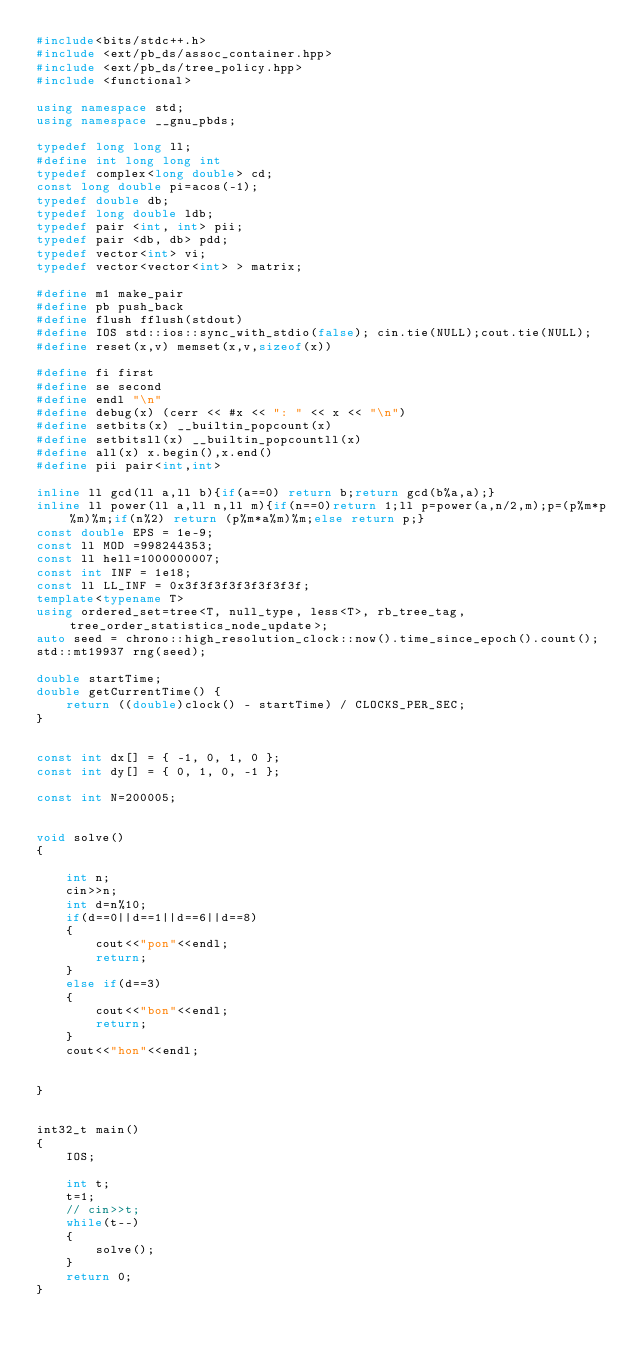Convert code to text. <code><loc_0><loc_0><loc_500><loc_500><_C++_>#include<bits/stdc++.h>
#include <ext/pb_ds/assoc_container.hpp>
#include <ext/pb_ds/tree_policy.hpp>
#include <functional>

using namespace std;
using namespace __gnu_pbds;

typedef long long ll;
#define int long long int
typedef complex<long double> cd;
const long double pi=acos(-1);
typedef double db;
typedef long double ldb;
typedef pair <int, int> pii;
typedef pair <db, db> pdd;
typedef vector<int> vi;
typedef vector<vector<int> > matrix;

#define m1 make_pair
#define pb push_back
#define flush fflush(stdout)
#define IOS std::ios::sync_with_stdio(false); cin.tie(NULL);cout.tie(NULL);
#define reset(x,v) memset(x,v,sizeof(x))

#define fi first
#define se second
#define endl "\n"
#define debug(x) (cerr << #x << ": " << x << "\n")
#define setbits(x) __builtin_popcount(x)
#define setbitsll(x) __builtin_popcountll(x)
#define all(x) x.begin(),x.end()
#define pii pair<int,int>

inline ll gcd(ll a,ll b){if(a==0) return b;return gcd(b%a,a);}
inline ll power(ll a,ll n,ll m){if(n==0)return 1;ll p=power(a,n/2,m);p=(p%m*p%m)%m;if(n%2) return (p%m*a%m)%m;else return p;}
const double EPS = 1e-9;
const ll MOD =998244353;
const ll hell=1000000007;
const int INF = 1e18;
const ll LL_INF = 0x3f3f3f3f3f3f3f3f;
template<typename T>
using ordered_set=tree<T, null_type, less<T>, rb_tree_tag,tree_order_statistics_node_update>;
auto seed = chrono::high_resolution_clock::now().time_since_epoch().count();
std::mt19937 rng(seed);

double startTime;
double getCurrentTime() {
    return ((double)clock() - startTime) / CLOCKS_PER_SEC;
}


const int dx[] = { -1, 0, 1, 0 };
const int dy[] = { 0, 1, 0, -1 };

const int N=200005;


void solve()
{

    int n;
    cin>>n;
    int d=n%10;
    if(d==0||d==1||d==6||d==8)
    {
        cout<<"pon"<<endl;
        return;
    }
    else if(d==3)
    {
        cout<<"bon"<<endl;
        return;
    }
    cout<<"hon"<<endl;
    
    
}


int32_t main()
{
    IOS;
    
    int t;
    t=1;
    // cin>>t;
    while(t--)
    {
        solve();
    }
    return 0;
}
</code> 